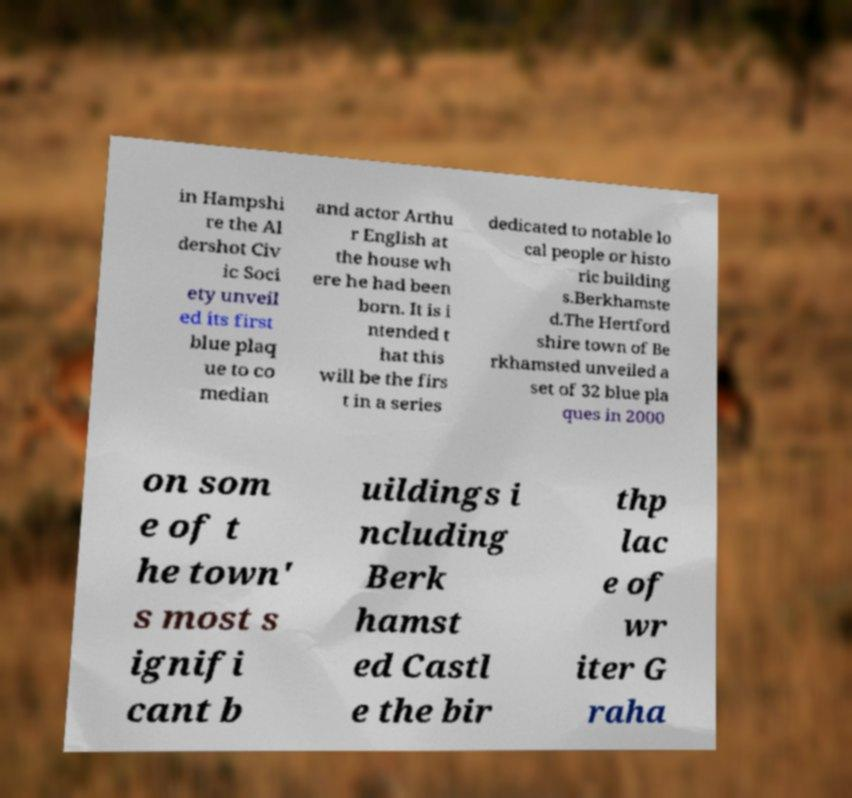For documentation purposes, I need the text within this image transcribed. Could you provide that? in Hampshi re the Al dershot Civ ic Soci ety unveil ed its first blue plaq ue to co median and actor Arthu r English at the house wh ere he had been born. It is i ntended t hat this will be the firs t in a series dedicated to notable lo cal people or histo ric building s.Berkhamste d.The Hertford shire town of Be rkhamsted unveiled a set of 32 blue pla ques in 2000 on som e of t he town' s most s ignifi cant b uildings i ncluding Berk hamst ed Castl e the bir thp lac e of wr iter G raha 